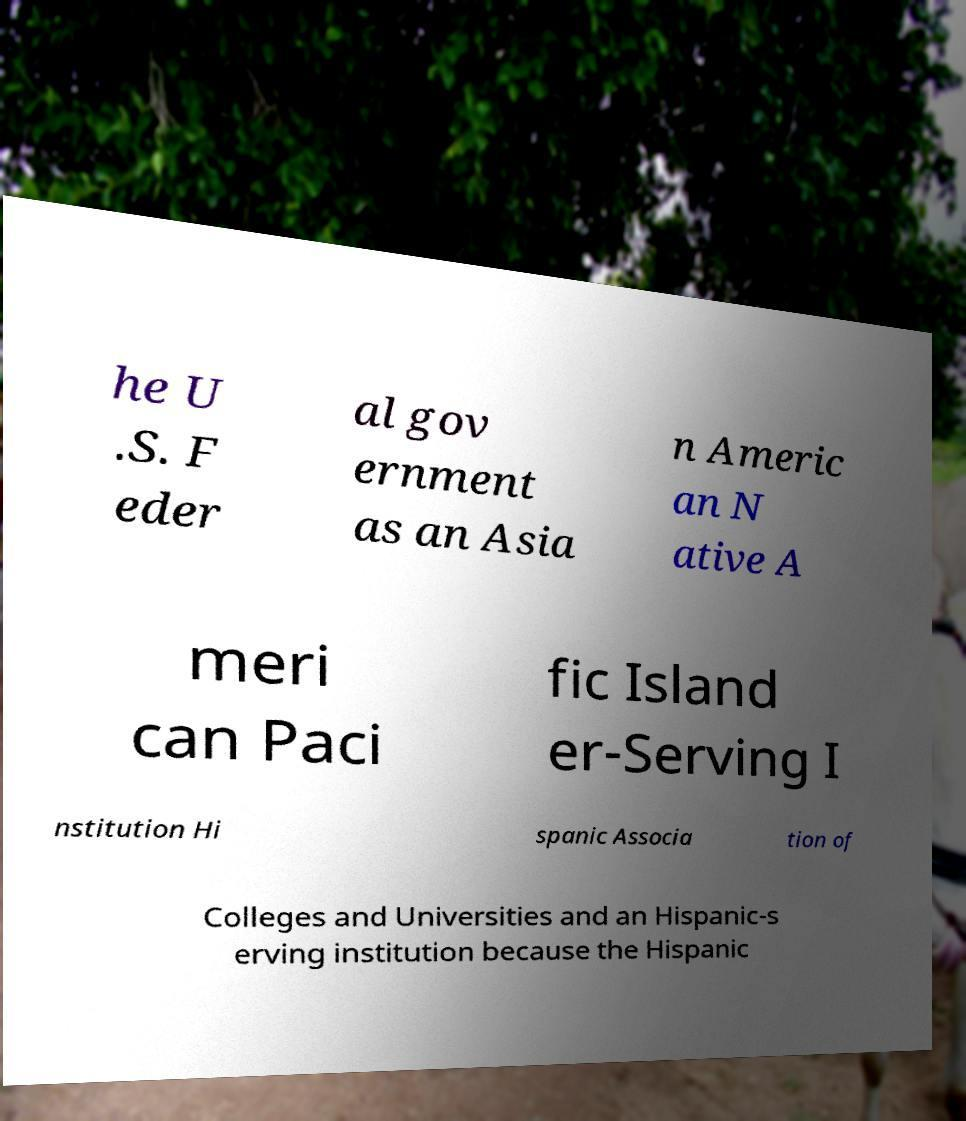For documentation purposes, I need the text within this image transcribed. Could you provide that? he U .S. F eder al gov ernment as an Asia n Americ an N ative A meri can Paci fic Island er-Serving I nstitution Hi spanic Associa tion of Colleges and Universities and an Hispanic-s erving institution because the Hispanic 